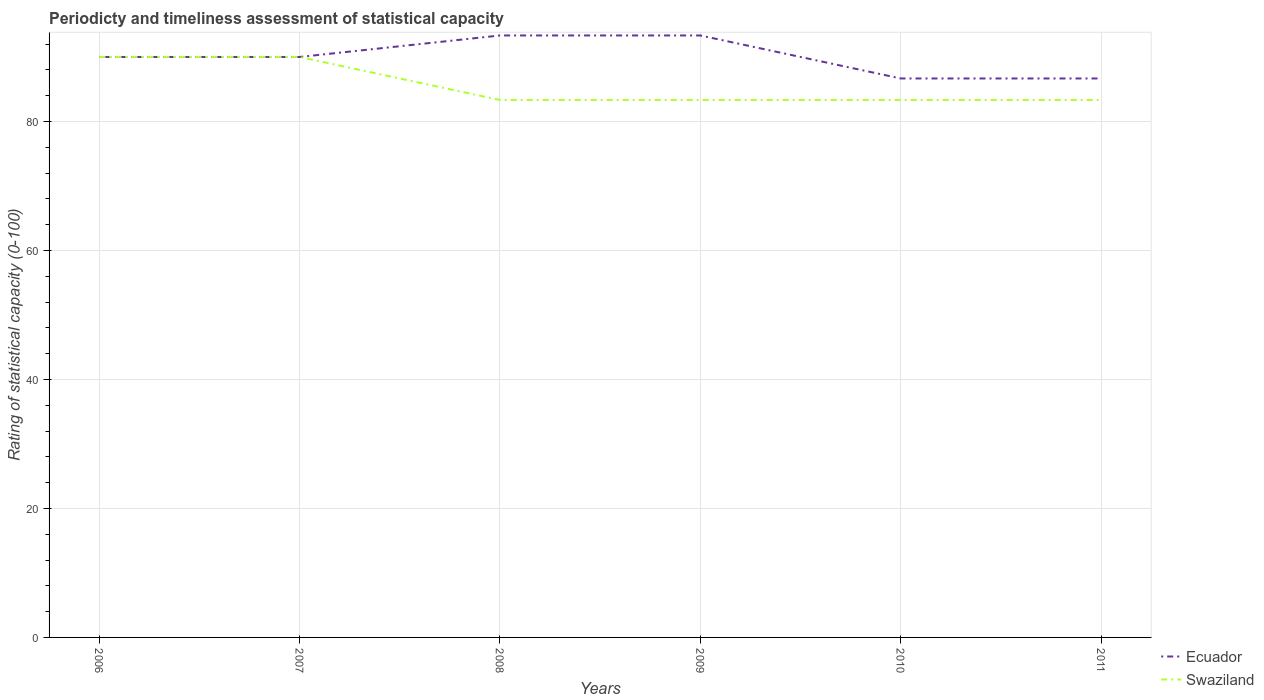How many different coloured lines are there?
Ensure brevity in your answer.  2. Across all years, what is the maximum rating of statistical capacity in Swaziland?
Make the answer very short. 83.33. In which year was the rating of statistical capacity in Ecuador maximum?
Offer a terse response. 2010. What is the total rating of statistical capacity in Ecuador in the graph?
Ensure brevity in your answer.  3.33. What is the difference between the highest and the second highest rating of statistical capacity in Swaziland?
Give a very brief answer. 6.67. What is the difference between the highest and the lowest rating of statistical capacity in Swaziland?
Provide a short and direct response. 2. Is the rating of statistical capacity in Swaziland strictly greater than the rating of statistical capacity in Ecuador over the years?
Keep it short and to the point. No. How many lines are there?
Provide a short and direct response. 2. What is the difference between two consecutive major ticks on the Y-axis?
Make the answer very short. 20. Does the graph contain grids?
Offer a very short reply. Yes. Where does the legend appear in the graph?
Provide a succinct answer. Bottom right. How are the legend labels stacked?
Provide a short and direct response. Vertical. What is the title of the graph?
Provide a short and direct response. Periodicty and timeliness assessment of statistical capacity. What is the label or title of the X-axis?
Your response must be concise. Years. What is the label or title of the Y-axis?
Keep it short and to the point. Rating of statistical capacity (0-100). What is the Rating of statistical capacity (0-100) in Swaziland in 2006?
Provide a short and direct response. 90. What is the Rating of statistical capacity (0-100) in Ecuador in 2007?
Give a very brief answer. 90. What is the Rating of statistical capacity (0-100) in Ecuador in 2008?
Offer a very short reply. 93.33. What is the Rating of statistical capacity (0-100) in Swaziland in 2008?
Ensure brevity in your answer.  83.33. What is the Rating of statistical capacity (0-100) in Ecuador in 2009?
Ensure brevity in your answer.  93.33. What is the Rating of statistical capacity (0-100) in Swaziland in 2009?
Your answer should be compact. 83.33. What is the Rating of statistical capacity (0-100) of Ecuador in 2010?
Your answer should be very brief. 86.67. What is the Rating of statistical capacity (0-100) in Swaziland in 2010?
Offer a terse response. 83.33. What is the Rating of statistical capacity (0-100) in Ecuador in 2011?
Give a very brief answer. 86.67. What is the Rating of statistical capacity (0-100) in Swaziland in 2011?
Your answer should be compact. 83.33. Across all years, what is the maximum Rating of statistical capacity (0-100) in Ecuador?
Give a very brief answer. 93.33. Across all years, what is the minimum Rating of statistical capacity (0-100) in Ecuador?
Your answer should be very brief. 86.67. Across all years, what is the minimum Rating of statistical capacity (0-100) in Swaziland?
Offer a terse response. 83.33. What is the total Rating of statistical capacity (0-100) in Ecuador in the graph?
Give a very brief answer. 540. What is the total Rating of statistical capacity (0-100) in Swaziland in the graph?
Ensure brevity in your answer.  513.33. What is the difference between the Rating of statistical capacity (0-100) in Ecuador in 2006 and that in 2007?
Keep it short and to the point. 0. What is the difference between the Rating of statistical capacity (0-100) of Swaziland in 2006 and that in 2007?
Your answer should be compact. 0. What is the difference between the Rating of statistical capacity (0-100) of Ecuador in 2006 and that in 2008?
Provide a short and direct response. -3.33. What is the difference between the Rating of statistical capacity (0-100) of Ecuador in 2006 and that in 2009?
Ensure brevity in your answer.  -3.33. What is the difference between the Rating of statistical capacity (0-100) of Swaziland in 2006 and that in 2009?
Give a very brief answer. 6.67. What is the difference between the Rating of statistical capacity (0-100) in Ecuador in 2006 and that in 2010?
Provide a succinct answer. 3.33. What is the difference between the Rating of statistical capacity (0-100) in Ecuador in 2007 and that in 2009?
Offer a terse response. -3.33. What is the difference between the Rating of statistical capacity (0-100) in Swaziland in 2007 and that in 2009?
Your answer should be compact. 6.67. What is the difference between the Rating of statistical capacity (0-100) in Ecuador in 2007 and that in 2010?
Your answer should be very brief. 3.33. What is the difference between the Rating of statistical capacity (0-100) of Swaziland in 2007 and that in 2011?
Keep it short and to the point. 6.67. What is the difference between the Rating of statistical capacity (0-100) of Ecuador in 2008 and that in 2009?
Offer a terse response. 0. What is the difference between the Rating of statistical capacity (0-100) of Swaziland in 2008 and that in 2011?
Ensure brevity in your answer.  0. What is the difference between the Rating of statistical capacity (0-100) in Swaziland in 2009 and that in 2010?
Your response must be concise. 0. What is the difference between the Rating of statistical capacity (0-100) in Ecuador in 2009 and that in 2011?
Provide a succinct answer. 6.67. What is the difference between the Rating of statistical capacity (0-100) of Swaziland in 2009 and that in 2011?
Provide a short and direct response. 0. What is the difference between the Rating of statistical capacity (0-100) of Ecuador in 2010 and that in 2011?
Keep it short and to the point. 0. What is the difference between the Rating of statistical capacity (0-100) in Swaziland in 2010 and that in 2011?
Keep it short and to the point. 0. What is the difference between the Rating of statistical capacity (0-100) of Ecuador in 2006 and the Rating of statistical capacity (0-100) of Swaziland in 2007?
Keep it short and to the point. 0. What is the difference between the Rating of statistical capacity (0-100) of Ecuador in 2006 and the Rating of statistical capacity (0-100) of Swaziland in 2008?
Ensure brevity in your answer.  6.67. What is the difference between the Rating of statistical capacity (0-100) in Ecuador in 2006 and the Rating of statistical capacity (0-100) in Swaziland in 2009?
Offer a terse response. 6.67. What is the difference between the Rating of statistical capacity (0-100) in Ecuador in 2006 and the Rating of statistical capacity (0-100) in Swaziland in 2011?
Offer a very short reply. 6.67. What is the difference between the Rating of statistical capacity (0-100) in Ecuador in 2007 and the Rating of statistical capacity (0-100) in Swaziland in 2010?
Offer a terse response. 6.67. What is the difference between the Rating of statistical capacity (0-100) in Ecuador in 2007 and the Rating of statistical capacity (0-100) in Swaziland in 2011?
Your answer should be compact. 6.67. What is the difference between the Rating of statistical capacity (0-100) of Ecuador in 2008 and the Rating of statistical capacity (0-100) of Swaziland in 2009?
Ensure brevity in your answer.  10. What is the difference between the Rating of statistical capacity (0-100) in Ecuador in 2008 and the Rating of statistical capacity (0-100) in Swaziland in 2010?
Your answer should be very brief. 10. What is the difference between the Rating of statistical capacity (0-100) in Ecuador in 2008 and the Rating of statistical capacity (0-100) in Swaziland in 2011?
Offer a terse response. 10. What is the difference between the Rating of statistical capacity (0-100) in Ecuador in 2010 and the Rating of statistical capacity (0-100) in Swaziland in 2011?
Keep it short and to the point. 3.33. What is the average Rating of statistical capacity (0-100) in Swaziland per year?
Offer a terse response. 85.56. In the year 2006, what is the difference between the Rating of statistical capacity (0-100) of Ecuador and Rating of statistical capacity (0-100) of Swaziland?
Keep it short and to the point. 0. In the year 2007, what is the difference between the Rating of statistical capacity (0-100) of Ecuador and Rating of statistical capacity (0-100) of Swaziland?
Keep it short and to the point. 0. In the year 2008, what is the difference between the Rating of statistical capacity (0-100) in Ecuador and Rating of statistical capacity (0-100) in Swaziland?
Your answer should be very brief. 10. In the year 2010, what is the difference between the Rating of statistical capacity (0-100) in Ecuador and Rating of statistical capacity (0-100) in Swaziland?
Make the answer very short. 3.33. What is the ratio of the Rating of statistical capacity (0-100) of Ecuador in 2006 to that in 2007?
Offer a terse response. 1. What is the ratio of the Rating of statistical capacity (0-100) in Swaziland in 2006 to that in 2008?
Make the answer very short. 1.08. What is the ratio of the Rating of statistical capacity (0-100) of Ecuador in 2007 to that in 2008?
Keep it short and to the point. 0.96. What is the ratio of the Rating of statistical capacity (0-100) in Swaziland in 2007 to that in 2008?
Give a very brief answer. 1.08. What is the ratio of the Rating of statistical capacity (0-100) of Ecuador in 2007 to that in 2010?
Your answer should be very brief. 1.04. What is the ratio of the Rating of statistical capacity (0-100) of Swaziland in 2007 to that in 2010?
Offer a terse response. 1.08. What is the ratio of the Rating of statistical capacity (0-100) in Ecuador in 2007 to that in 2011?
Offer a very short reply. 1.04. What is the ratio of the Rating of statistical capacity (0-100) of Swaziland in 2007 to that in 2011?
Keep it short and to the point. 1.08. What is the ratio of the Rating of statistical capacity (0-100) of Swaziland in 2008 to that in 2010?
Provide a succinct answer. 1. What is the ratio of the Rating of statistical capacity (0-100) of Swaziland in 2008 to that in 2011?
Your answer should be very brief. 1. What is the ratio of the Rating of statistical capacity (0-100) in Ecuador in 2009 to that in 2011?
Your response must be concise. 1.08. What is the difference between the highest and the second highest Rating of statistical capacity (0-100) in Swaziland?
Provide a succinct answer. 0. What is the difference between the highest and the lowest Rating of statistical capacity (0-100) in Ecuador?
Offer a terse response. 6.67. What is the difference between the highest and the lowest Rating of statistical capacity (0-100) in Swaziland?
Your response must be concise. 6.67. 